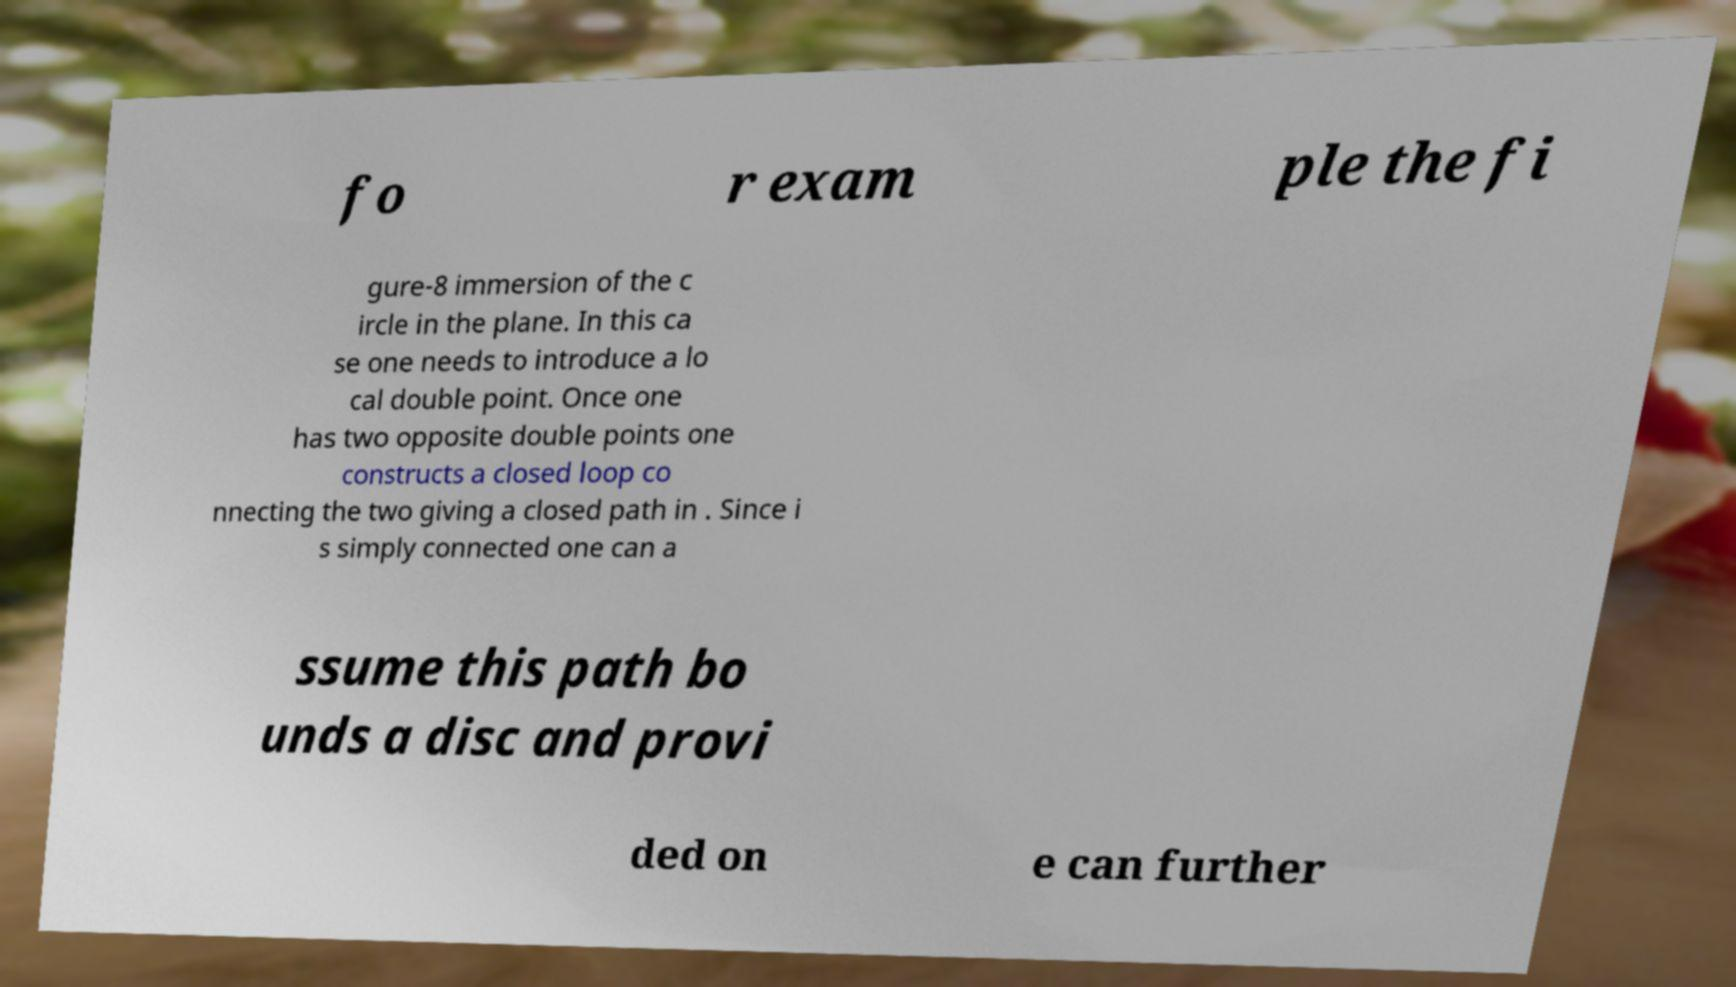Can you accurately transcribe the text from the provided image for me? fo r exam ple the fi gure-8 immersion of the c ircle in the plane. In this ca se one needs to introduce a lo cal double point. Once one has two opposite double points one constructs a closed loop co nnecting the two giving a closed path in . Since i s simply connected one can a ssume this path bo unds a disc and provi ded on e can further 